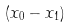Convert formula to latex. <formula><loc_0><loc_0><loc_500><loc_500>( x _ { 0 } - x _ { 1 } )</formula> 